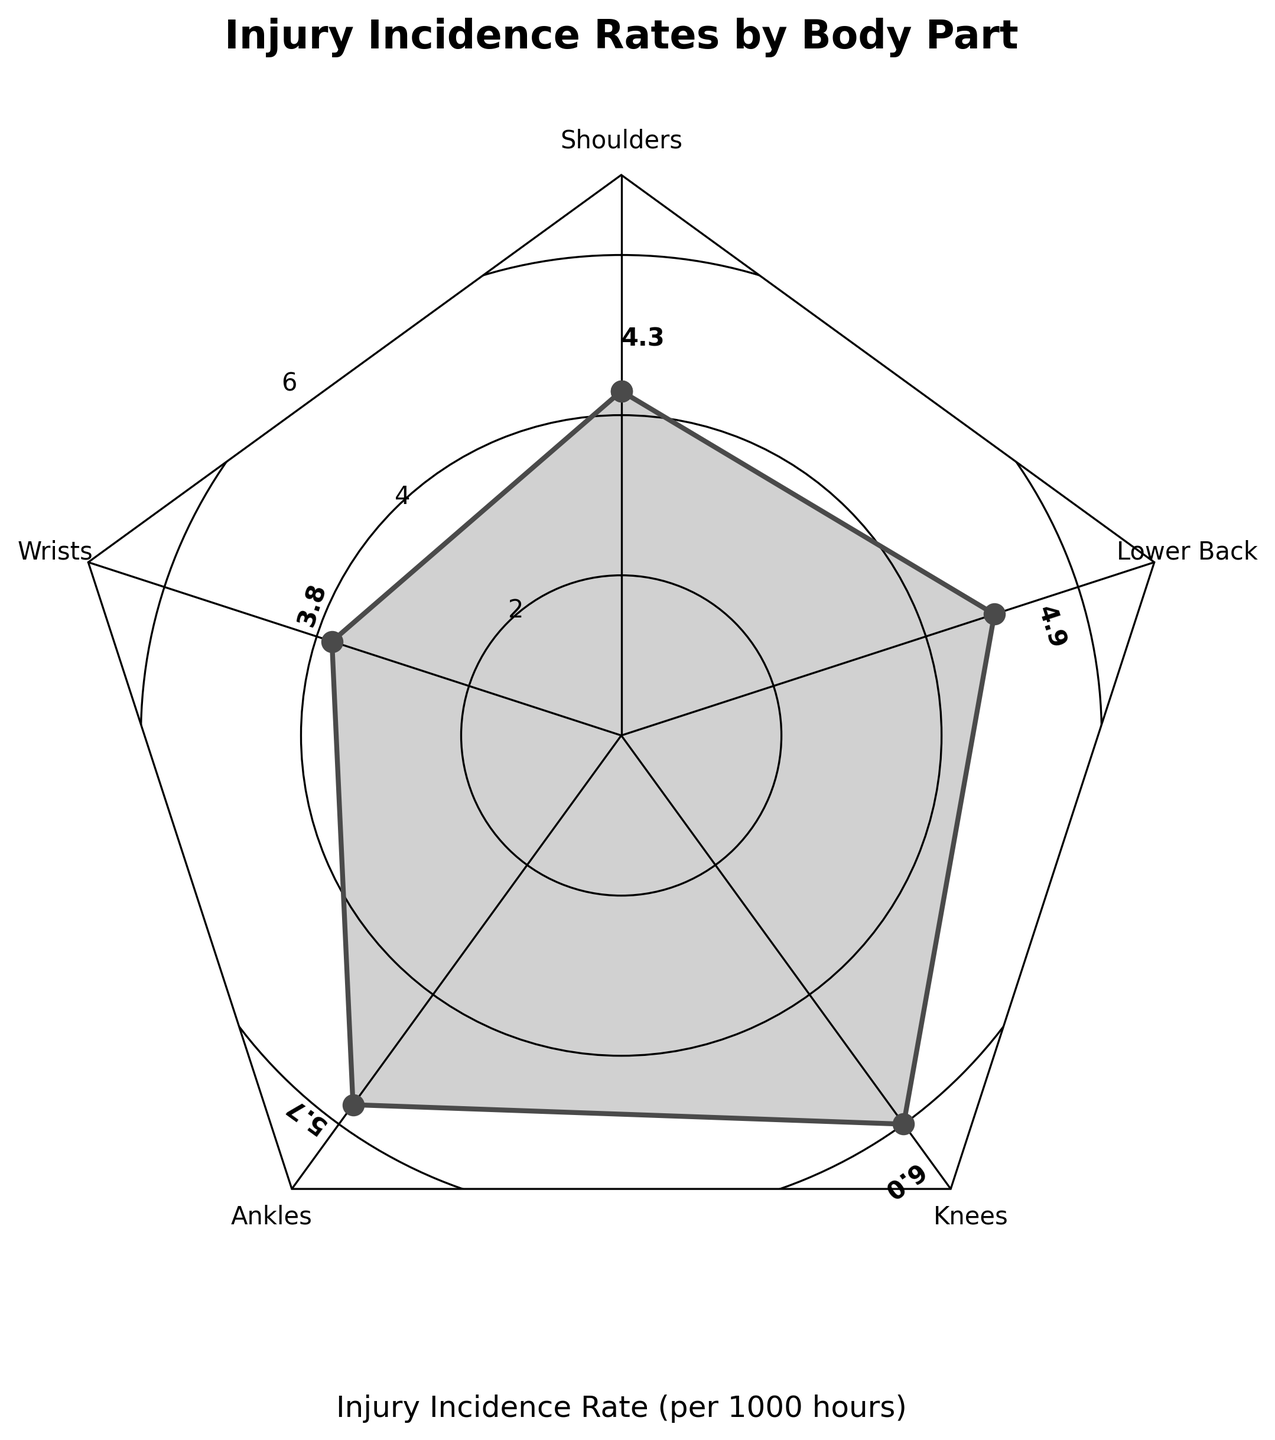Which body part has the highest injury incidence rate? To determine the body part with the highest injury incidence rate, look at the values displayed along the lines and find the largest one in the radar chart. The highest rate is 6.0 for Knees.
Answer: Knees Which body part has the lowest injury incidence rate? To determine the body part with the lowest injury incidence rate, look at the values displayed along the lines and find the smallest one in the radar chart. The lowest rate is 3.8 for Wrists.
Answer: Wrists What is the difference in injury incidence rates between shoulders and lower back? To find this difference, locate both the shoulder and lower back values on the radar chart. These values are 4.3 for shoulders and 4.9 for lower back. Calculate the difference as 4.9 - 4.3 = 0.6.
Answer: 0.6 What is the average injury incidence rate across all body parts? To find the average, sum up all the incidence rates from the radar chart: 4.3 (Shoulders) + 3.8 (Wrists) + 5.7 (Ankles) + 6.0 (Knees) + 4.9 (Lower Back) = 24.7. Then, divide by the number of body parts, which is 5. So, 24.7 / 5 = 4.94.
Answer: 4.94 What is the median value of injury incidence rates? To find the median, first sort the rates: 3.8, 4.3, 4.9, 5.7, 6.0. The middle value is the third one in the sorted list, which is 4.9.
Answer: 4.9 How does the injury incidence rate for ankles compare to the shoulders? Compare the values for ankles and shoulders from the radar chart. The values are 5.7 for ankles and 4.3 for shoulders. Since 5.7 is greater than 4.3, the injury rate for ankles is higher.
Answer: Ankles have a higher rate than shoulders What is the total injury incidence rate for all body parts combined? To find the total, sum up all the incidence rates from the radar chart: 4.3 (Shoulders) + 3.8 (Wrists) + 5.7 (Ankles) + 6.0 (Knees) + 4.9 (Lower Back) = 24.7.
Answer: 24.7 Which body parts have an injury incidence rate above the average? First, determine the average value, which is 4.94 as earlier calculated. Then, identify the body parts with rates above this average, which are Ankles (5.7) and Knees (6.0).
Answer: Ankles, Knees What's the difference between the highest and lowest injury incidence rates? To find this difference, determine the highest and lowest rates which are 6.0 (Knees) and 3.8 (Wrists), respectively. Calculate the difference as 6.0 - 3.8 = 2.2.
Answer: 2.2 